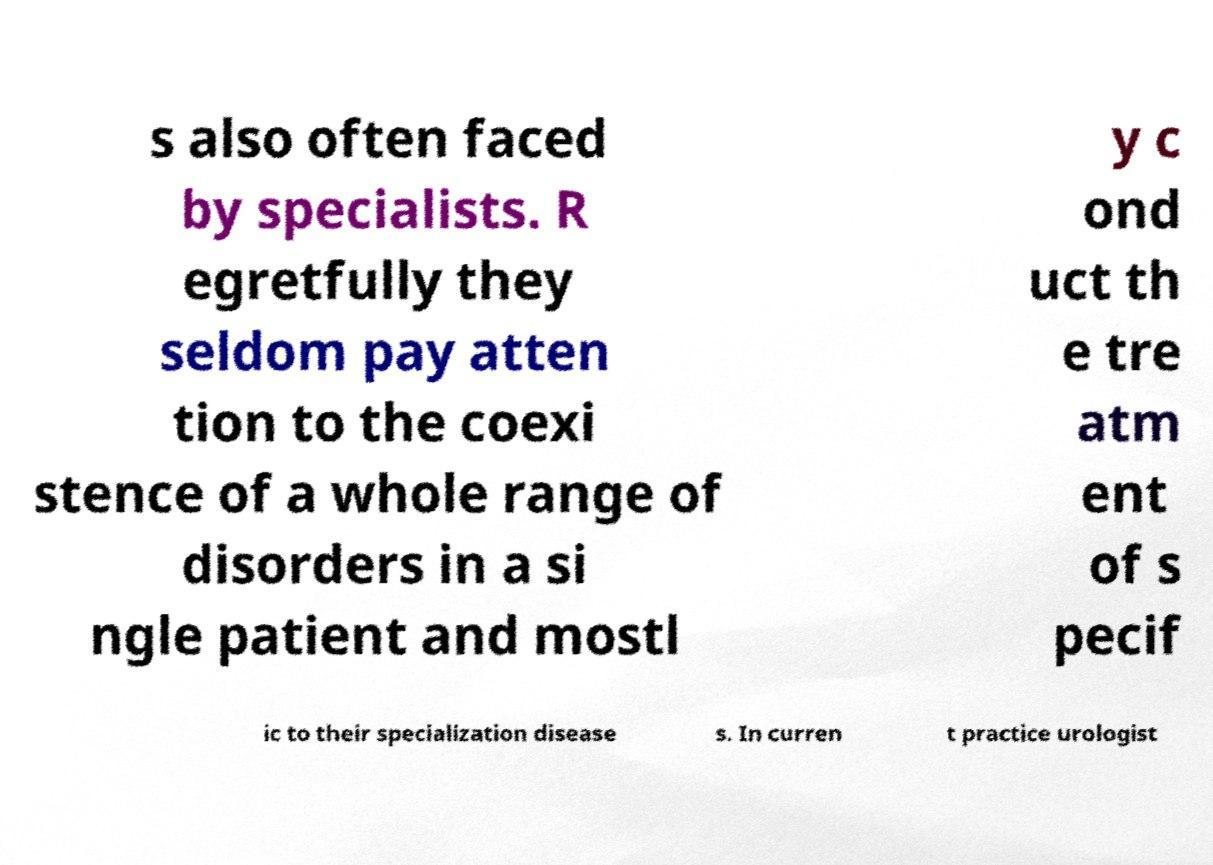For documentation purposes, I need the text within this image transcribed. Could you provide that? s also often faced by specialists. R egretfully they seldom pay atten tion to the coexi stence of a whole range of disorders in a si ngle patient and mostl y c ond uct th e tre atm ent of s pecif ic to their specialization disease s. In curren t practice urologist 